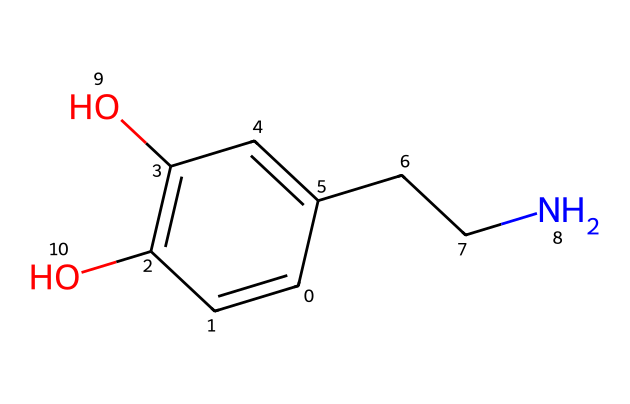What is the molecular formula of dopamine? To find the molecular formula, count the number of each type of atom in the SMILES representation: 8 carbon (C), 11 hydrogen (H), 2 oxygen (O), and 1 nitrogen (N). Thus, the molecular formula is C8H11NO2.
Answer: C8H11NO2 How many carbon atoms are in dopamine? By examining the SMILES, carbon atoms are counted directly; there are 8 carbon atoms present.
Answer: 8 What functional groups are present in dopamine? Analyze the structure formed by the SMILES. Dopamine contains a phenolic hydroxyl group (-OH) and an amine group (-NH2), indicating that it has phenolic and amine functional groups.
Answer: phenolic and amine What is the significance of the nitrogen atom in dopamine? The nitrogen atom indicates the presence of an amine, which is critical for dopamine's role as a neurotransmitter, affecting its interactions with receptors in the nervous system.
Answer: neurotransmitter How many total bonds are there in the dopamine structure? To find the total number of bonds, consider each bond represented in the SMILES: there are 12 total bonds formed (counting double and single bonds).
Answer: 12 How many hydroxyl (-OH) groups does dopamine have? The SMILES shows two instances of the -OH group, indicating that there are two hydroxyl groups in the structure of dopamine.
Answer: 2 Why is dopamine classified as a neurotransmitter? Dopamine has a specific structure that allows it to interact with neurotransmitter receptors in the nervous system, which is vital for signaling related to reward and motivation.
Answer: signaling 